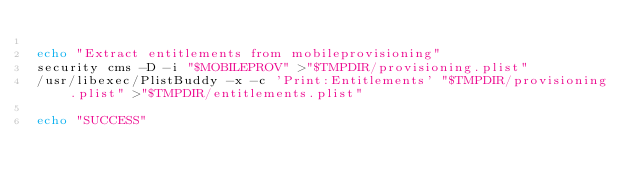<code> <loc_0><loc_0><loc_500><loc_500><_Bash_>
echo "Extract entitlements from mobileprovisioning"
security cms -D -i "$MOBILEPROV" >"$TMPDIR/provisioning.plist"
/usr/libexec/PlistBuddy -x -c 'Print:Entitlements' "$TMPDIR/provisioning.plist" >"$TMPDIR/entitlements.plist"

echo "SUCCESS"
</code> 